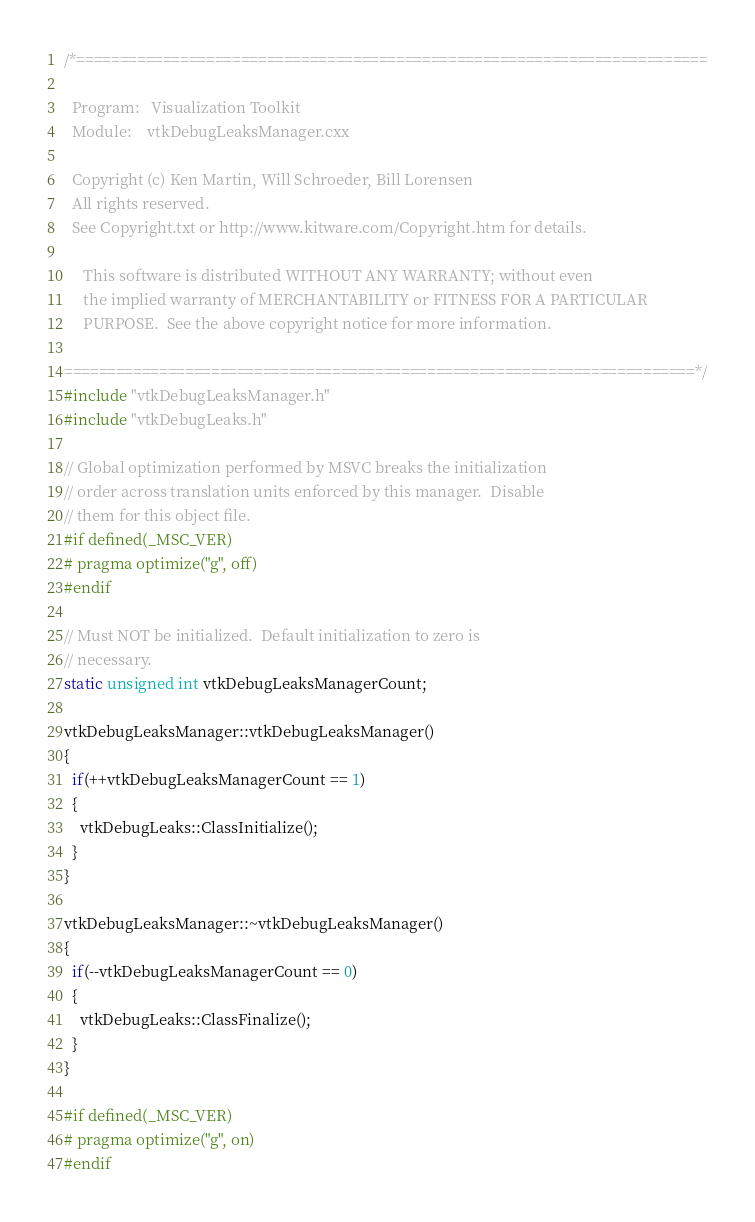<code> <loc_0><loc_0><loc_500><loc_500><_C++_>/*=========================================================================

  Program:   Visualization Toolkit
  Module:    vtkDebugLeaksManager.cxx

  Copyright (c) Ken Martin, Will Schroeder, Bill Lorensen
  All rights reserved.
  See Copyright.txt or http://www.kitware.com/Copyright.htm for details.

     This software is distributed WITHOUT ANY WARRANTY; without even
     the implied warranty of MERCHANTABILITY or FITNESS FOR A PARTICULAR
     PURPOSE.  See the above copyright notice for more information.

=========================================================================*/
#include "vtkDebugLeaksManager.h"
#include "vtkDebugLeaks.h"

// Global optimization performed by MSVC breaks the initialization
// order across translation units enforced by this manager.  Disable
// them for this object file.
#if defined(_MSC_VER)
# pragma optimize("g", off)
#endif

// Must NOT be initialized.  Default initialization to zero is
// necessary.
static unsigned int vtkDebugLeaksManagerCount;

vtkDebugLeaksManager::vtkDebugLeaksManager()
{
  if(++vtkDebugLeaksManagerCount == 1)
  {
    vtkDebugLeaks::ClassInitialize();
  }
}

vtkDebugLeaksManager::~vtkDebugLeaksManager()
{
  if(--vtkDebugLeaksManagerCount == 0)
  {
    vtkDebugLeaks::ClassFinalize();
  }
}

#if defined(_MSC_VER)
# pragma optimize("g", on)
#endif
</code> 